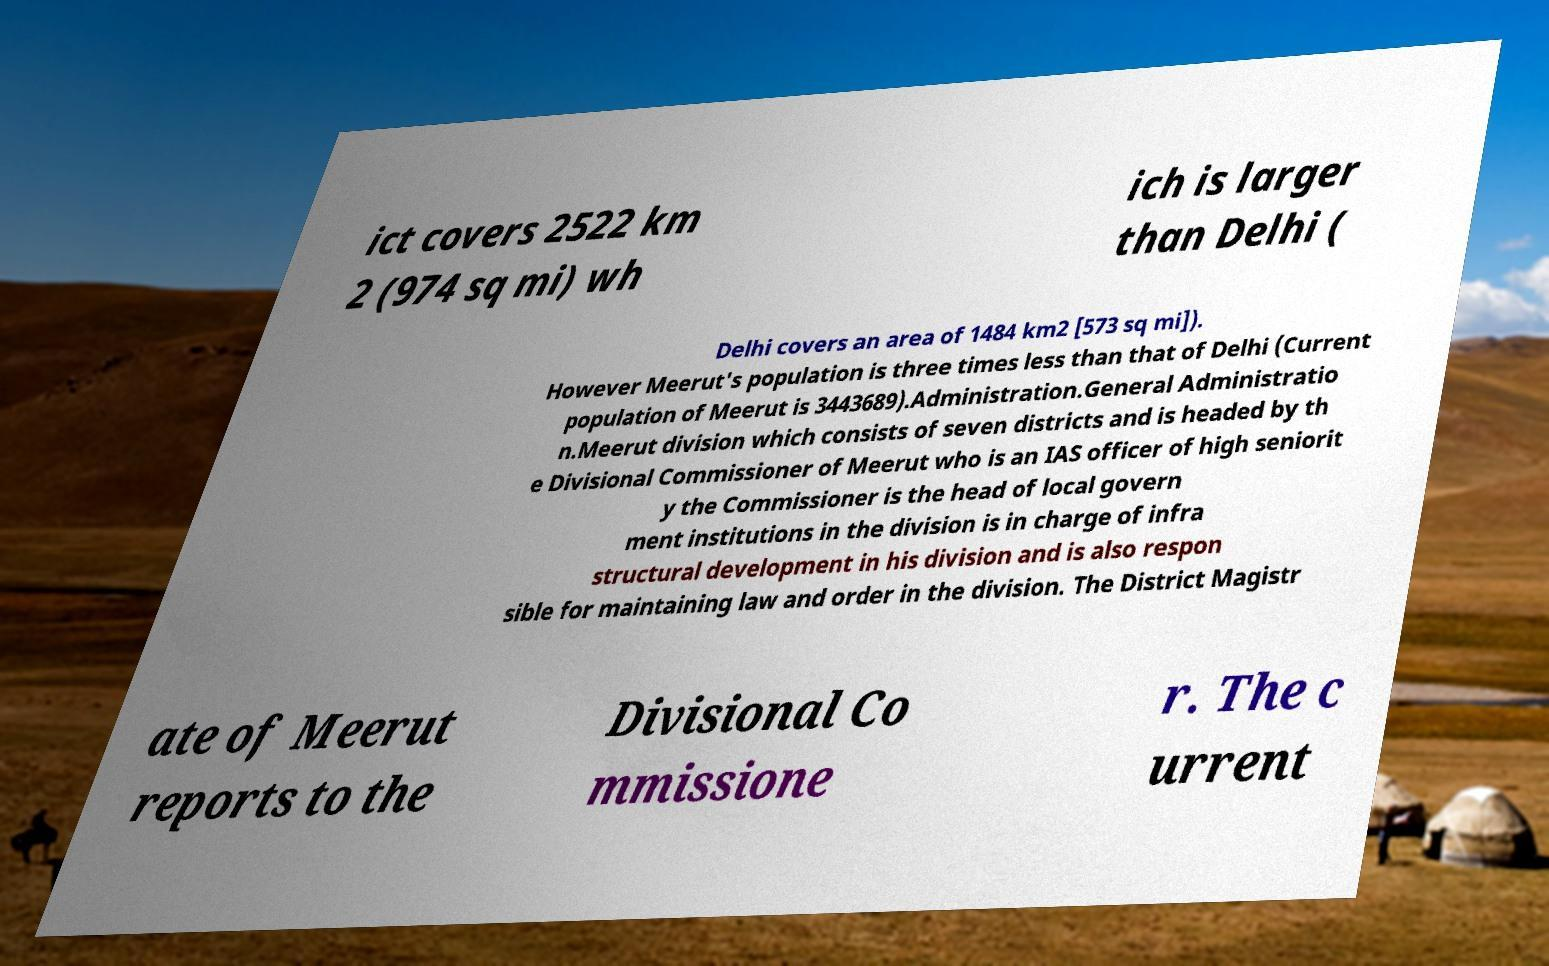Can you accurately transcribe the text from the provided image for me? ict covers 2522 km 2 (974 sq mi) wh ich is larger than Delhi ( Delhi covers an area of 1484 km2 [573 sq mi]). However Meerut's population is three times less than that of Delhi (Current population of Meerut is 3443689).Administration.General Administratio n.Meerut division which consists of seven districts and is headed by th e Divisional Commissioner of Meerut who is an IAS officer of high seniorit y the Commissioner is the head of local govern ment institutions in the division is in charge of infra structural development in his division and is also respon sible for maintaining law and order in the division. The District Magistr ate of Meerut reports to the Divisional Co mmissione r. The c urrent 